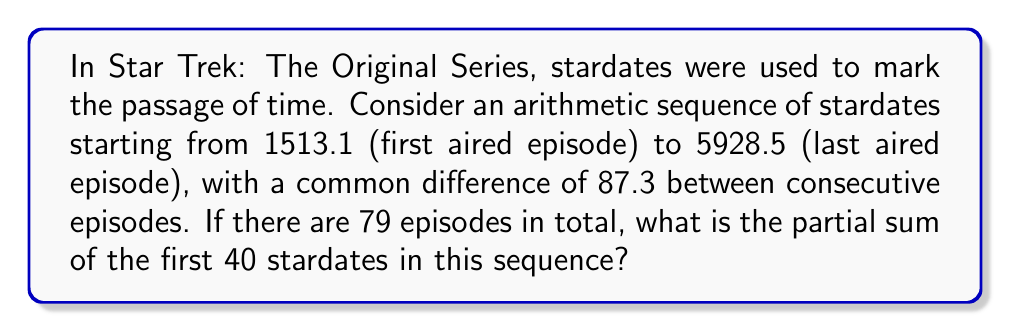Provide a solution to this math problem. Let's approach this step-by-step:

1) First, we need to identify the components of our arithmetic sequence:
   $a_1 = 1513.1$ (first term)
   $d = 87.3$ (common difference)
   $n = 40$ (number of terms for partial sum)

2) For an arithmetic sequence, the nth term is given by:
   $a_n = a_1 + (n-1)d$

3) The formula for the partial sum of an arithmetic sequence is:
   $S_n = \frac{n}{2}(a_1 + a_n)$

4) We need to find $a_{40}$ to use in our partial sum formula:
   $a_{40} = 1513.1 + (40-1)(87.3)$
   $a_{40} = 1513.1 + (39)(87.3)$
   $a_{40} = 1513.1 + 3404.7$
   $a_{40} = 4917.8$

5) Now we can plug this into our partial sum formula:
   $S_{40} = \frac{40}{2}(1513.1 + 4917.8)$
   $S_{40} = 20(6430.9)$
   $S_{40} = 128,618$

Therefore, the partial sum of the first 40 stardates in this sequence is 128,618.
Answer: 128,618 